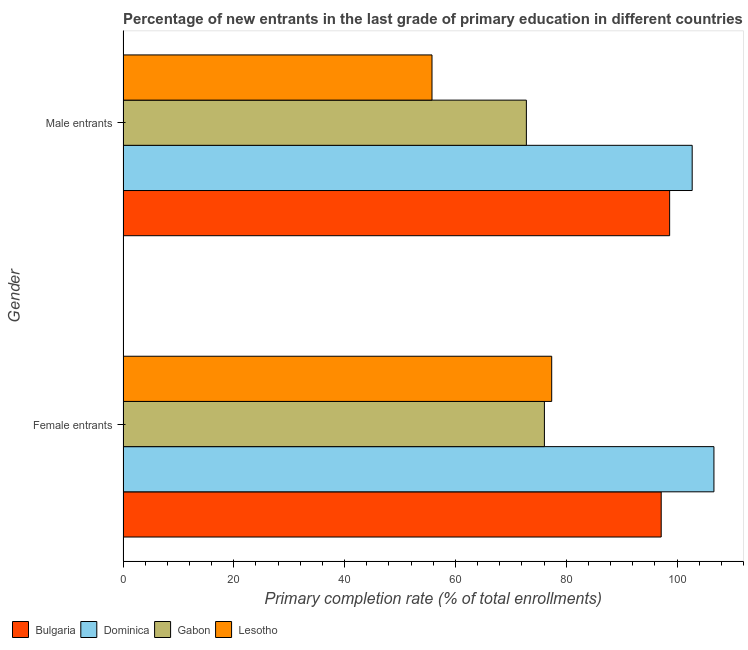How many bars are there on the 1st tick from the top?
Your answer should be very brief. 4. How many bars are there on the 2nd tick from the bottom?
Your response must be concise. 4. What is the label of the 2nd group of bars from the top?
Give a very brief answer. Female entrants. What is the primary completion rate of male entrants in Lesotho?
Keep it short and to the point. 55.78. Across all countries, what is the maximum primary completion rate of male entrants?
Provide a succinct answer. 102.74. Across all countries, what is the minimum primary completion rate of male entrants?
Offer a very short reply. 55.78. In which country was the primary completion rate of male entrants maximum?
Provide a succinct answer. Dominica. In which country was the primary completion rate of female entrants minimum?
Offer a very short reply. Gabon. What is the total primary completion rate of male entrants in the graph?
Ensure brevity in your answer.  329.99. What is the difference between the primary completion rate of female entrants in Lesotho and that in Gabon?
Ensure brevity in your answer.  1.32. What is the difference between the primary completion rate of male entrants in Bulgaria and the primary completion rate of female entrants in Dominica?
Your answer should be very brief. -8. What is the average primary completion rate of female entrants per country?
Provide a succinct answer. 89.32. What is the difference between the primary completion rate of male entrants and primary completion rate of female entrants in Bulgaria?
Provide a short and direct response. 1.52. What is the ratio of the primary completion rate of female entrants in Lesotho to that in Bulgaria?
Offer a very short reply. 0.8. Is the primary completion rate of female entrants in Dominica less than that in Gabon?
Your answer should be compact. No. What does the 1st bar from the top in Female entrants represents?
Your answer should be very brief. Lesotho. What does the 1st bar from the bottom in Male entrants represents?
Offer a very short reply. Bulgaria. How many countries are there in the graph?
Make the answer very short. 4. Does the graph contain grids?
Offer a terse response. No. Where does the legend appear in the graph?
Your answer should be very brief. Bottom left. How many legend labels are there?
Ensure brevity in your answer.  4. How are the legend labels stacked?
Your answer should be compact. Horizontal. What is the title of the graph?
Provide a short and direct response. Percentage of new entrants in the last grade of primary education in different countries. What is the label or title of the X-axis?
Make the answer very short. Primary completion rate (% of total enrollments). What is the Primary completion rate (% of total enrollments) of Bulgaria in Female entrants?
Offer a terse response. 97.15. What is the Primary completion rate (% of total enrollments) in Dominica in Female entrants?
Keep it short and to the point. 106.67. What is the Primary completion rate (% of total enrollments) of Gabon in Female entrants?
Your answer should be very brief. 76.07. What is the Primary completion rate (% of total enrollments) in Lesotho in Female entrants?
Give a very brief answer. 77.38. What is the Primary completion rate (% of total enrollments) in Bulgaria in Male entrants?
Provide a succinct answer. 98.67. What is the Primary completion rate (% of total enrollments) in Dominica in Male entrants?
Give a very brief answer. 102.74. What is the Primary completion rate (% of total enrollments) in Gabon in Male entrants?
Offer a terse response. 72.81. What is the Primary completion rate (% of total enrollments) in Lesotho in Male entrants?
Ensure brevity in your answer.  55.78. Across all Gender, what is the maximum Primary completion rate (% of total enrollments) of Bulgaria?
Your answer should be very brief. 98.67. Across all Gender, what is the maximum Primary completion rate (% of total enrollments) in Dominica?
Offer a terse response. 106.67. Across all Gender, what is the maximum Primary completion rate (% of total enrollments) of Gabon?
Provide a succinct answer. 76.07. Across all Gender, what is the maximum Primary completion rate (% of total enrollments) in Lesotho?
Your answer should be very brief. 77.38. Across all Gender, what is the minimum Primary completion rate (% of total enrollments) of Bulgaria?
Offer a terse response. 97.15. Across all Gender, what is the minimum Primary completion rate (% of total enrollments) of Dominica?
Give a very brief answer. 102.74. Across all Gender, what is the minimum Primary completion rate (% of total enrollments) of Gabon?
Make the answer very short. 72.81. Across all Gender, what is the minimum Primary completion rate (% of total enrollments) of Lesotho?
Make the answer very short. 55.78. What is the total Primary completion rate (% of total enrollments) in Bulgaria in the graph?
Keep it short and to the point. 195.82. What is the total Primary completion rate (% of total enrollments) in Dominica in the graph?
Make the answer very short. 209.41. What is the total Primary completion rate (% of total enrollments) in Gabon in the graph?
Offer a very short reply. 148.88. What is the total Primary completion rate (% of total enrollments) of Lesotho in the graph?
Keep it short and to the point. 133.16. What is the difference between the Primary completion rate (% of total enrollments) of Bulgaria in Female entrants and that in Male entrants?
Your answer should be very brief. -1.52. What is the difference between the Primary completion rate (% of total enrollments) in Dominica in Female entrants and that in Male entrants?
Provide a succinct answer. 3.93. What is the difference between the Primary completion rate (% of total enrollments) in Gabon in Female entrants and that in Male entrants?
Make the answer very short. 3.26. What is the difference between the Primary completion rate (% of total enrollments) of Lesotho in Female entrants and that in Male entrants?
Ensure brevity in your answer.  21.61. What is the difference between the Primary completion rate (% of total enrollments) of Bulgaria in Female entrants and the Primary completion rate (% of total enrollments) of Dominica in Male entrants?
Your answer should be very brief. -5.59. What is the difference between the Primary completion rate (% of total enrollments) of Bulgaria in Female entrants and the Primary completion rate (% of total enrollments) of Gabon in Male entrants?
Keep it short and to the point. 24.34. What is the difference between the Primary completion rate (% of total enrollments) of Bulgaria in Female entrants and the Primary completion rate (% of total enrollments) of Lesotho in Male entrants?
Offer a terse response. 41.37. What is the difference between the Primary completion rate (% of total enrollments) of Dominica in Female entrants and the Primary completion rate (% of total enrollments) of Gabon in Male entrants?
Your response must be concise. 33.86. What is the difference between the Primary completion rate (% of total enrollments) of Dominica in Female entrants and the Primary completion rate (% of total enrollments) of Lesotho in Male entrants?
Your response must be concise. 50.89. What is the difference between the Primary completion rate (% of total enrollments) of Gabon in Female entrants and the Primary completion rate (% of total enrollments) of Lesotho in Male entrants?
Keep it short and to the point. 20.29. What is the average Primary completion rate (% of total enrollments) of Bulgaria per Gender?
Make the answer very short. 97.91. What is the average Primary completion rate (% of total enrollments) in Dominica per Gender?
Provide a succinct answer. 104.7. What is the average Primary completion rate (% of total enrollments) in Gabon per Gender?
Ensure brevity in your answer.  74.44. What is the average Primary completion rate (% of total enrollments) in Lesotho per Gender?
Ensure brevity in your answer.  66.58. What is the difference between the Primary completion rate (% of total enrollments) of Bulgaria and Primary completion rate (% of total enrollments) of Dominica in Female entrants?
Offer a terse response. -9.52. What is the difference between the Primary completion rate (% of total enrollments) in Bulgaria and Primary completion rate (% of total enrollments) in Gabon in Female entrants?
Give a very brief answer. 21.08. What is the difference between the Primary completion rate (% of total enrollments) in Bulgaria and Primary completion rate (% of total enrollments) in Lesotho in Female entrants?
Give a very brief answer. 19.77. What is the difference between the Primary completion rate (% of total enrollments) in Dominica and Primary completion rate (% of total enrollments) in Gabon in Female entrants?
Provide a short and direct response. 30.6. What is the difference between the Primary completion rate (% of total enrollments) in Dominica and Primary completion rate (% of total enrollments) in Lesotho in Female entrants?
Your answer should be very brief. 29.29. What is the difference between the Primary completion rate (% of total enrollments) in Gabon and Primary completion rate (% of total enrollments) in Lesotho in Female entrants?
Offer a very short reply. -1.32. What is the difference between the Primary completion rate (% of total enrollments) of Bulgaria and Primary completion rate (% of total enrollments) of Dominica in Male entrants?
Give a very brief answer. -4.07. What is the difference between the Primary completion rate (% of total enrollments) of Bulgaria and Primary completion rate (% of total enrollments) of Gabon in Male entrants?
Your answer should be compact. 25.86. What is the difference between the Primary completion rate (% of total enrollments) of Bulgaria and Primary completion rate (% of total enrollments) of Lesotho in Male entrants?
Give a very brief answer. 42.89. What is the difference between the Primary completion rate (% of total enrollments) in Dominica and Primary completion rate (% of total enrollments) in Gabon in Male entrants?
Give a very brief answer. 29.93. What is the difference between the Primary completion rate (% of total enrollments) in Dominica and Primary completion rate (% of total enrollments) in Lesotho in Male entrants?
Give a very brief answer. 46.96. What is the difference between the Primary completion rate (% of total enrollments) in Gabon and Primary completion rate (% of total enrollments) in Lesotho in Male entrants?
Keep it short and to the point. 17.03. What is the ratio of the Primary completion rate (% of total enrollments) in Bulgaria in Female entrants to that in Male entrants?
Provide a short and direct response. 0.98. What is the ratio of the Primary completion rate (% of total enrollments) of Dominica in Female entrants to that in Male entrants?
Offer a terse response. 1.04. What is the ratio of the Primary completion rate (% of total enrollments) of Gabon in Female entrants to that in Male entrants?
Offer a terse response. 1.04. What is the ratio of the Primary completion rate (% of total enrollments) in Lesotho in Female entrants to that in Male entrants?
Your answer should be very brief. 1.39. What is the difference between the highest and the second highest Primary completion rate (% of total enrollments) in Bulgaria?
Offer a terse response. 1.52. What is the difference between the highest and the second highest Primary completion rate (% of total enrollments) of Dominica?
Your response must be concise. 3.93. What is the difference between the highest and the second highest Primary completion rate (% of total enrollments) in Gabon?
Ensure brevity in your answer.  3.26. What is the difference between the highest and the second highest Primary completion rate (% of total enrollments) in Lesotho?
Your response must be concise. 21.61. What is the difference between the highest and the lowest Primary completion rate (% of total enrollments) of Bulgaria?
Ensure brevity in your answer.  1.52. What is the difference between the highest and the lowest Primary completion rate (% of total enrollments) of Dominica?
Your answer should be very brief. 3.93. What is the difference between the highest and the lowest Primary completion rate (% of total enrollments) of Gabon?
Offer a very short reply. 3.26. What is the difference between the highest and the lowest Primary completion rate (% of total enrollments) in Lesotho?
Provide a succinct answer. 21.61. 